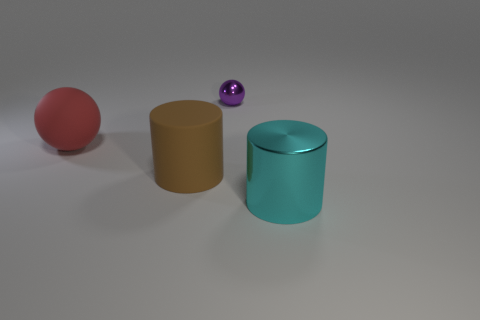Add 3 blue metallic spheres. How many objects exist? 7 Subtract all small green spheres. Subtract all large metallic cylinders. How many objects are left? 3 Add 4 big cyan shiny things. How many big cyan shiny things are left? 5 Add 4 big spheres. How many big spheres exist? 5 Subtract 0 purple cylinders. How many objects are left? 4 